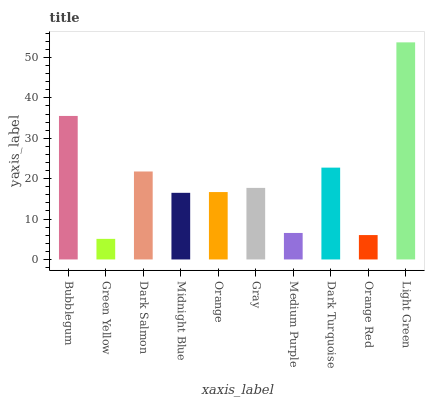Is Green Yellow the minimum?
Answer yes or no. Yes. Is Light Green the maximum?
Answer yes or no. Yes. Is Dark Salmon the minimum?
Answer yes or no. No. Is Dark Salmon the maximum?
Answer yes or no. No. Is Dark Salmon greater than Green Yellow?
Answer yes or no. Yes. Is Green Yellow less than Dark Salmon?
Answer yes or no. Yes. Is Green Yellow greater than Dark Salmon?
Answer yes or no. No. Is Dark Salmon less than Green Yellow?
Answer yes or no. No. Is Gray the high median?
Answer yes or no. Yes. Is Orange the low median?
Answer yes or no. Yes. Is Green Yellow the high median?
Answer yes or no. No. Is Dark Salmon the low median?
Answer yes or no. No. 